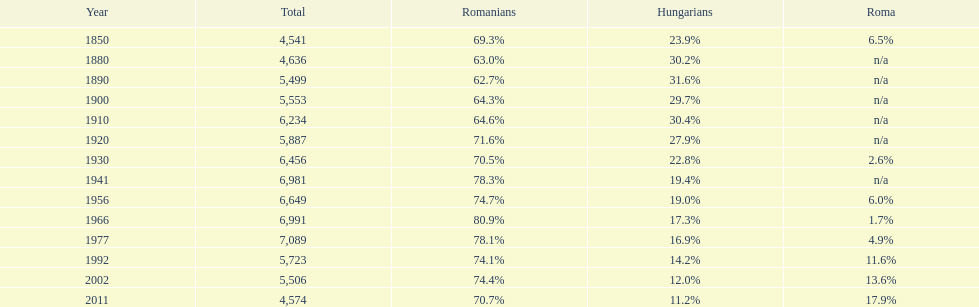1% romanian population precede? 1977. 